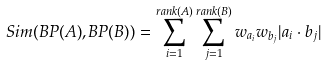<formula> <loc_0><loc_0><loc_500><loc_500>S i m ( B P ( A ) , B P ( B ) ) = \sum ^ { r a n k ( A ) } _ { i = 1 } \sum ^ { r a n k ( B ) } _ { j = 1 } w _ { a _ { i } } w _ { b _ { j } } | a _ { i } \cdot b _ { j } |</formula> 